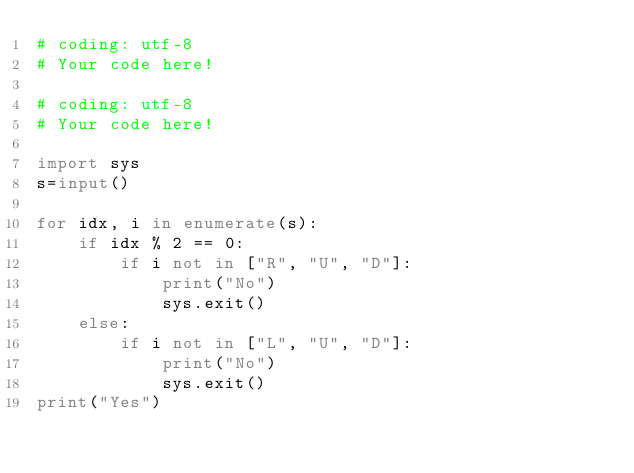Convert code to text. <code><loc_0><loc_0><loc_500><loc_500><_Python_># coding: utf-8
# Your code here!

# coding: utf-8
# Your code here!

import sys
s=input()

for idx, i in enumerate(s):
    if idx % 2 == 0:
        if i not in ["R", "U", "D"]:
            print("No")
            sys.exit()
    else:
        if i not in ["L", "U", "D"]:
            print("No")
            sys.exit()
print("Yes")</code> 